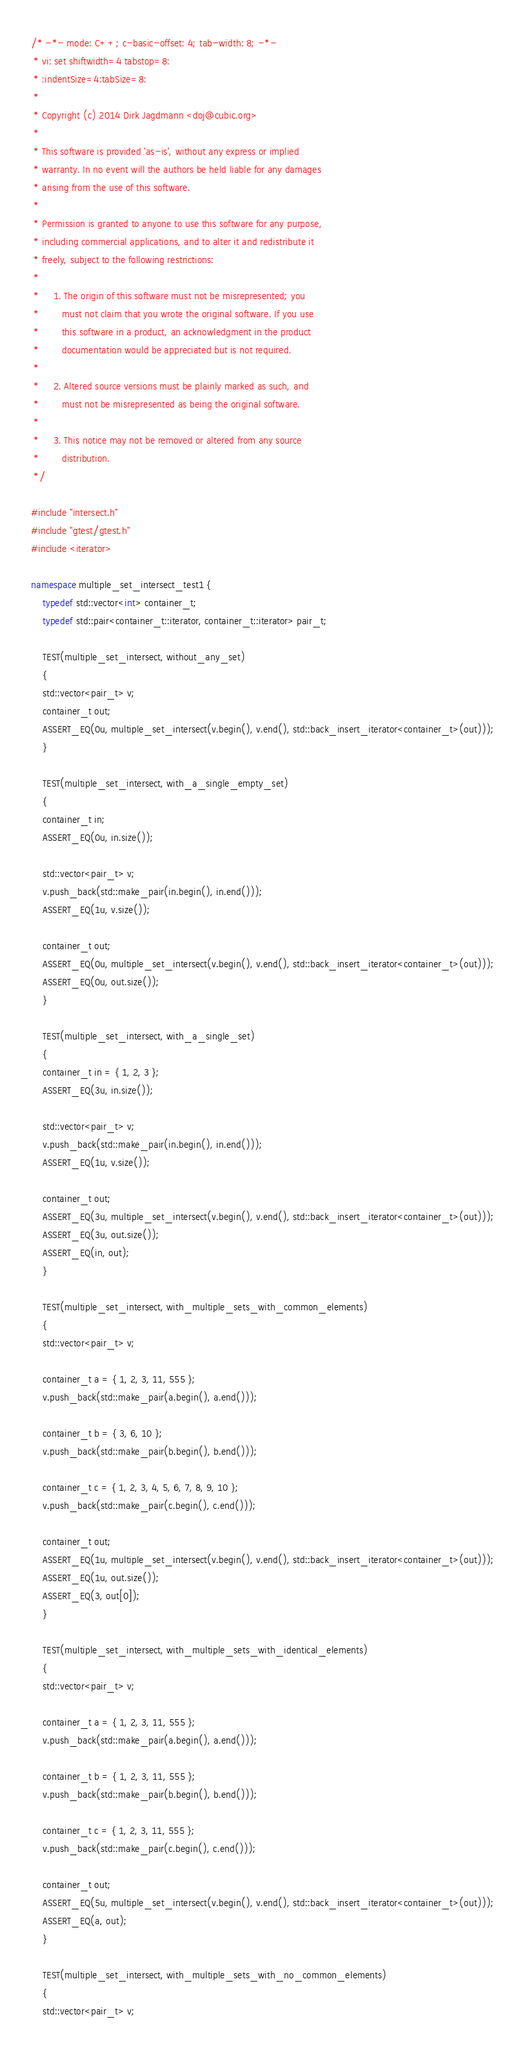Convert code to text. <code><loc_0><loc_0><loc_500><loc_500><_C++_>/* -*- mode: C++; c-basic-offset: 4; tab-width: 8; -*-
 * vi: set shiftwidth=4 tabstop=8:
 * :indentSize=4:tabSize=8:
 *
 * Copyright (c) 2014 Dirk Jagdmann <doj@cubic.org>
 *
 * This software is provided 'as-is', without any express or implied
 * warranty. In no event will the authors be held liable for any damages
 * arising from the use of this software.
 *
 * Permission is granted to anyone to use this software for any purpose,
 * including commercial applications, and to alter it and redistribute it
 * freely, subject to the following restrictions:
 *
 *     1. The origin of this software must not be misrepresented; you
 *        must not claim that you wrote the original software. If you use
 *        this software in a product, an acknowledgment in the product
 *        documentation would be appreciated but is not required.
 *
 *     2. Altered source versions must be plainly marked as such, and
 *        must not be misrepresented as being the original software.
 *
 *     3. This notice may not be removed or altered from any source
 *        distribution.
 */

#include "intersect.h"
#include "gtest/gtest.h"
#include <iterator>

namespace multiple_set_intersect_test1 {
    typedef std::vector<int> container_t;
    typedef std::pair<container_t::iterator, container_t::iterator> pair_t;

    TEST(multiple_set_intersect, without_any_set)
    {
	std::vector<pair_t> v;
	container_t out;
	ASSERT_EQ(0u, multiple_set_intersect(v.begin(), v.end(), std::back_insert_iterator<container_t>(out)));
    }

    TEST(multiple_set_intersect, with_a_single_empty_set)
    {
	container_t in;
	ASSERT_EQ(0u, in.size());

	std::vector<pair_t> v;
	v.push_back(std::make_pair(in.begin(), in.end()));
	ASSERT_EQ(1u, v.size());

	container_t out;
	ASSERT_EQ(0u, multiple_set_intersect(v.begin(), v.end(), std::back_insert_iterator<container_t>(out)));
	ASSERT_EQ(0u, out.size());
    }

    TEST(multiple_set_intersect, with_a_single_set)
    {
	container_t in = { 1, 2, 3 };
	ASSERT_EQ(3u, in.size());

	std::vector<pair_t> v;
	v.push_back(std::make_pair(in.begin(), in.end()));
	ASSERT_EQ(1u, v.size());

	container_t out;
	ASSERT_EQ(3u, multiple_set_intersect(v.begin(), v.end(), std::back_insert_iterator<container_t>(out)));
	ASSERT_EQ(3u, out.size());
	ASSERT_EQ(in, out);
    }

    TEST(multiple_set_intersect, with_multiple_sets_with_common_elements)
    {
	std::vector<pair_t> v;

	container_t a = { 1, 2, 3, 11, 555 };
	v.push_back(std::make_pair(a.begin(), a.end()));

	container_t b = { 3, 6, 10 };
	v.push_back(std::make_pair(b.begin(), b.end()));

	container_t c = { 1, 2, 3, 4, 5, 6, 7, 8, 9, 10 };
	v.push_back(std::make_pair(c.begin(), c.end()));

	container_t out;
	ASSERT_EQ(1u, multiple_set_intersect(v.begin(), v.end(), std::back_insert_iterator<container_t>(out)));
	ASSERT_EQ(1u, out.size());
	ASSERT_EQ(3, out[0]);
    }

    TEST(multiple_set_intersect, with_multiple_sets_with_identical_elements)
    {
	std::vector<pair_t> v;

	container_t a = { 1, 2, 3, 11, 555 };
	v.push_back(std::make_pair(a.begin(), a.end()));

	container_t b = { 1, 2, 3, 11, 555 };
	v.push_back(std::make_pair(b.begin(), b.end()));

	container_t c = { 1, 2, 3, 11, 555 };
	v.push_back(std::make_pair(c.begin(), c.end()));

	container_t out;
	ASSERT_EQ(5u, multiple_set_intersect(v.begin(), v.end(), std::back_insert_iterator<container_t>(out)));
	ASSERT_EQ(a, out);
    }

    TEST(multiple_set_intersect, with_multiple_sets_with_no_common_elements)
    {
	std::vector<pair_t> v;
</code> 